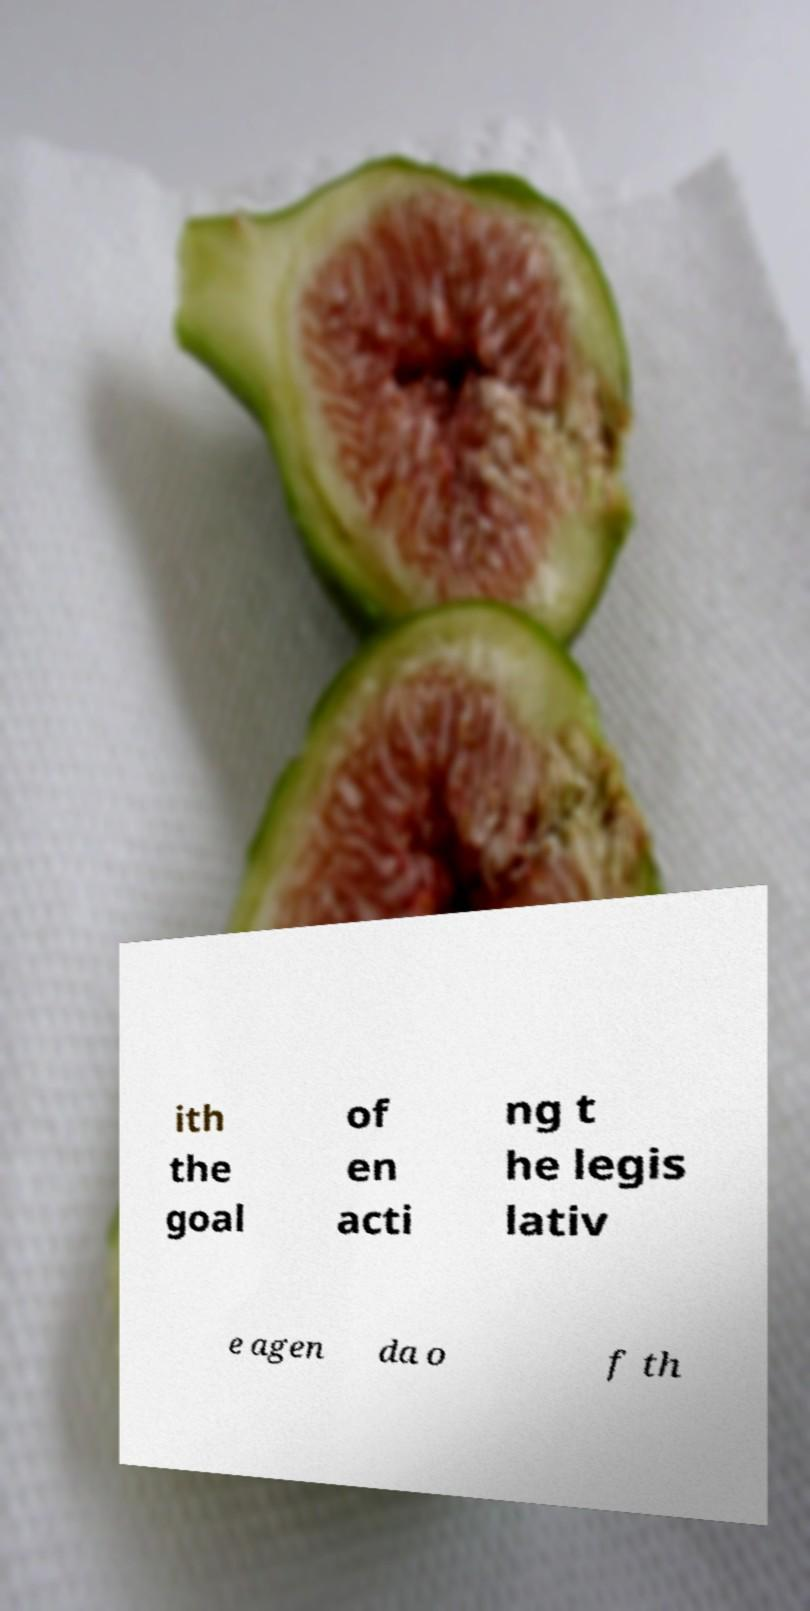Can you read and provide the text displayed in the image?This photo seems to have some interesting text. Can you extract and type it out for me? ith the goal of en acti ng t he legis lativ e agen da o f th 